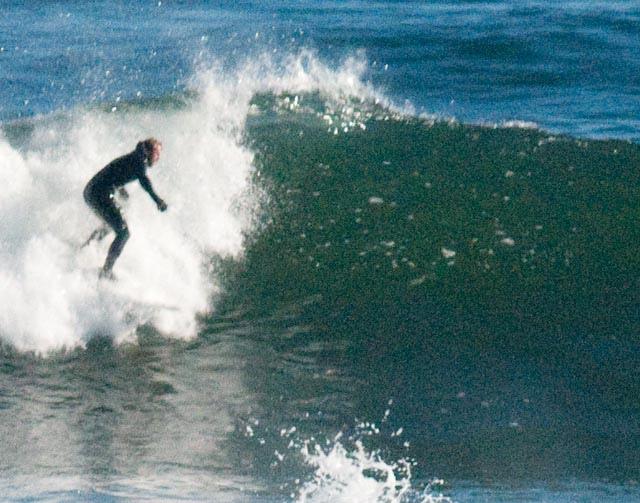What activity is taking place in this picture?
Be succinct. Surfing. Is the surfer scared?
Answer briefly. No. Is the water calm?
Give a very brief answer. No. Where is the person?
Be succinct. Ocean. 